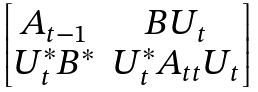<formula> <loc_0><loc_0><loc_500><loc_500>\begin{bmatrix} A _ { t - 1 } & B U _ { t } \\ U _ { t } ^ { * } B ^ { * } & U _ { t } ^ { * } A _ { t t } U _ { t } \end{bmatrix}</formula> 